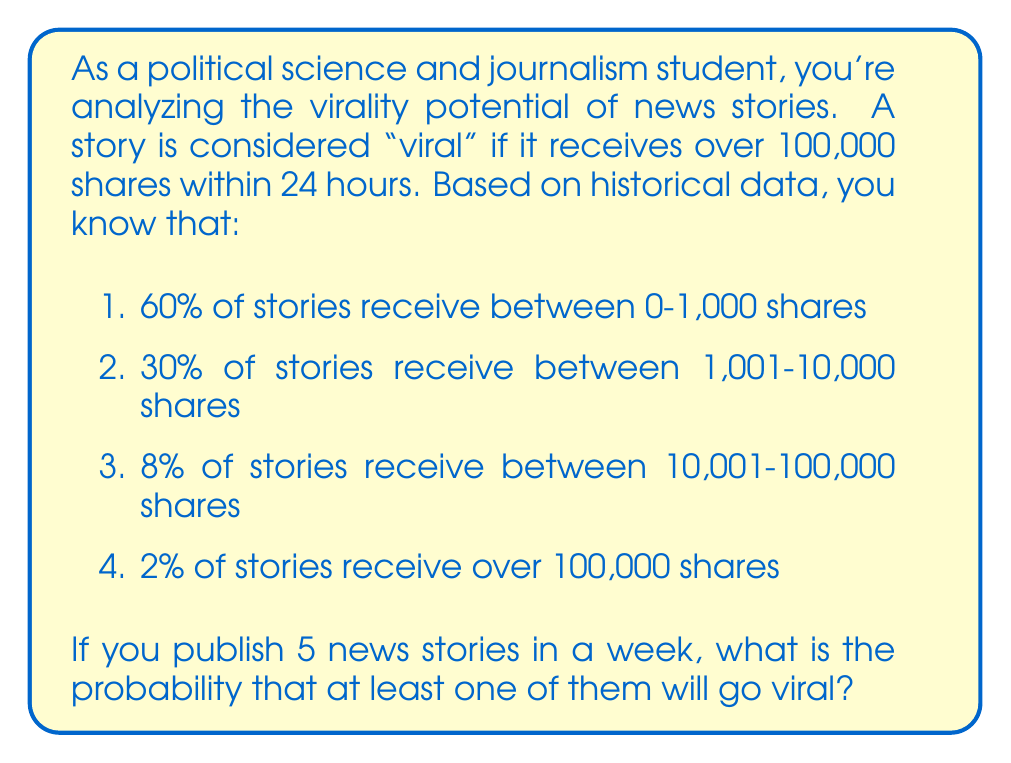Can you solve this math problem? Let's approach this step-by-step:

1. First, we need to identify the probability of a single story going viral. From the given data, we know that 2% of stories receive over 100,000 shares, which is our definition of "viral". So, the probability of a single story going viral is:

   $p(\text{viral}) = 0.02$

2. Now, we need to find the probability of at least one story out of 5 going viral. It's often easier to calculate the complement of this event - the probability that none of the 5 stories go viral.

3. The probability of a story not going viral is:

   $p(\text{not viral}) = 1 - p(\text{viral}) = 1 - 0.02 = 0.98$

4. For none of the 5 stories to go viral, each story must not go viral. Assuming independence, we can multiply these probabilities:

   $p(\text{none viral}) = 0.98^5 = 0.9039$

5. Therefore, the probability of at least one story going viral is the complement of this:

   $p(\text{at least one viral}) = 1 - p(\text{none viral}) = 1 - 0.9039 = 0.0961$

6. Converting to a percentage:

   $0.0961 \times 100\% = 9.61\%$
Answer: 9.61% 